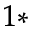<formula> <loc_0><loc_0><loc_500><loc_500>^ { 1 \ast }</formula> 